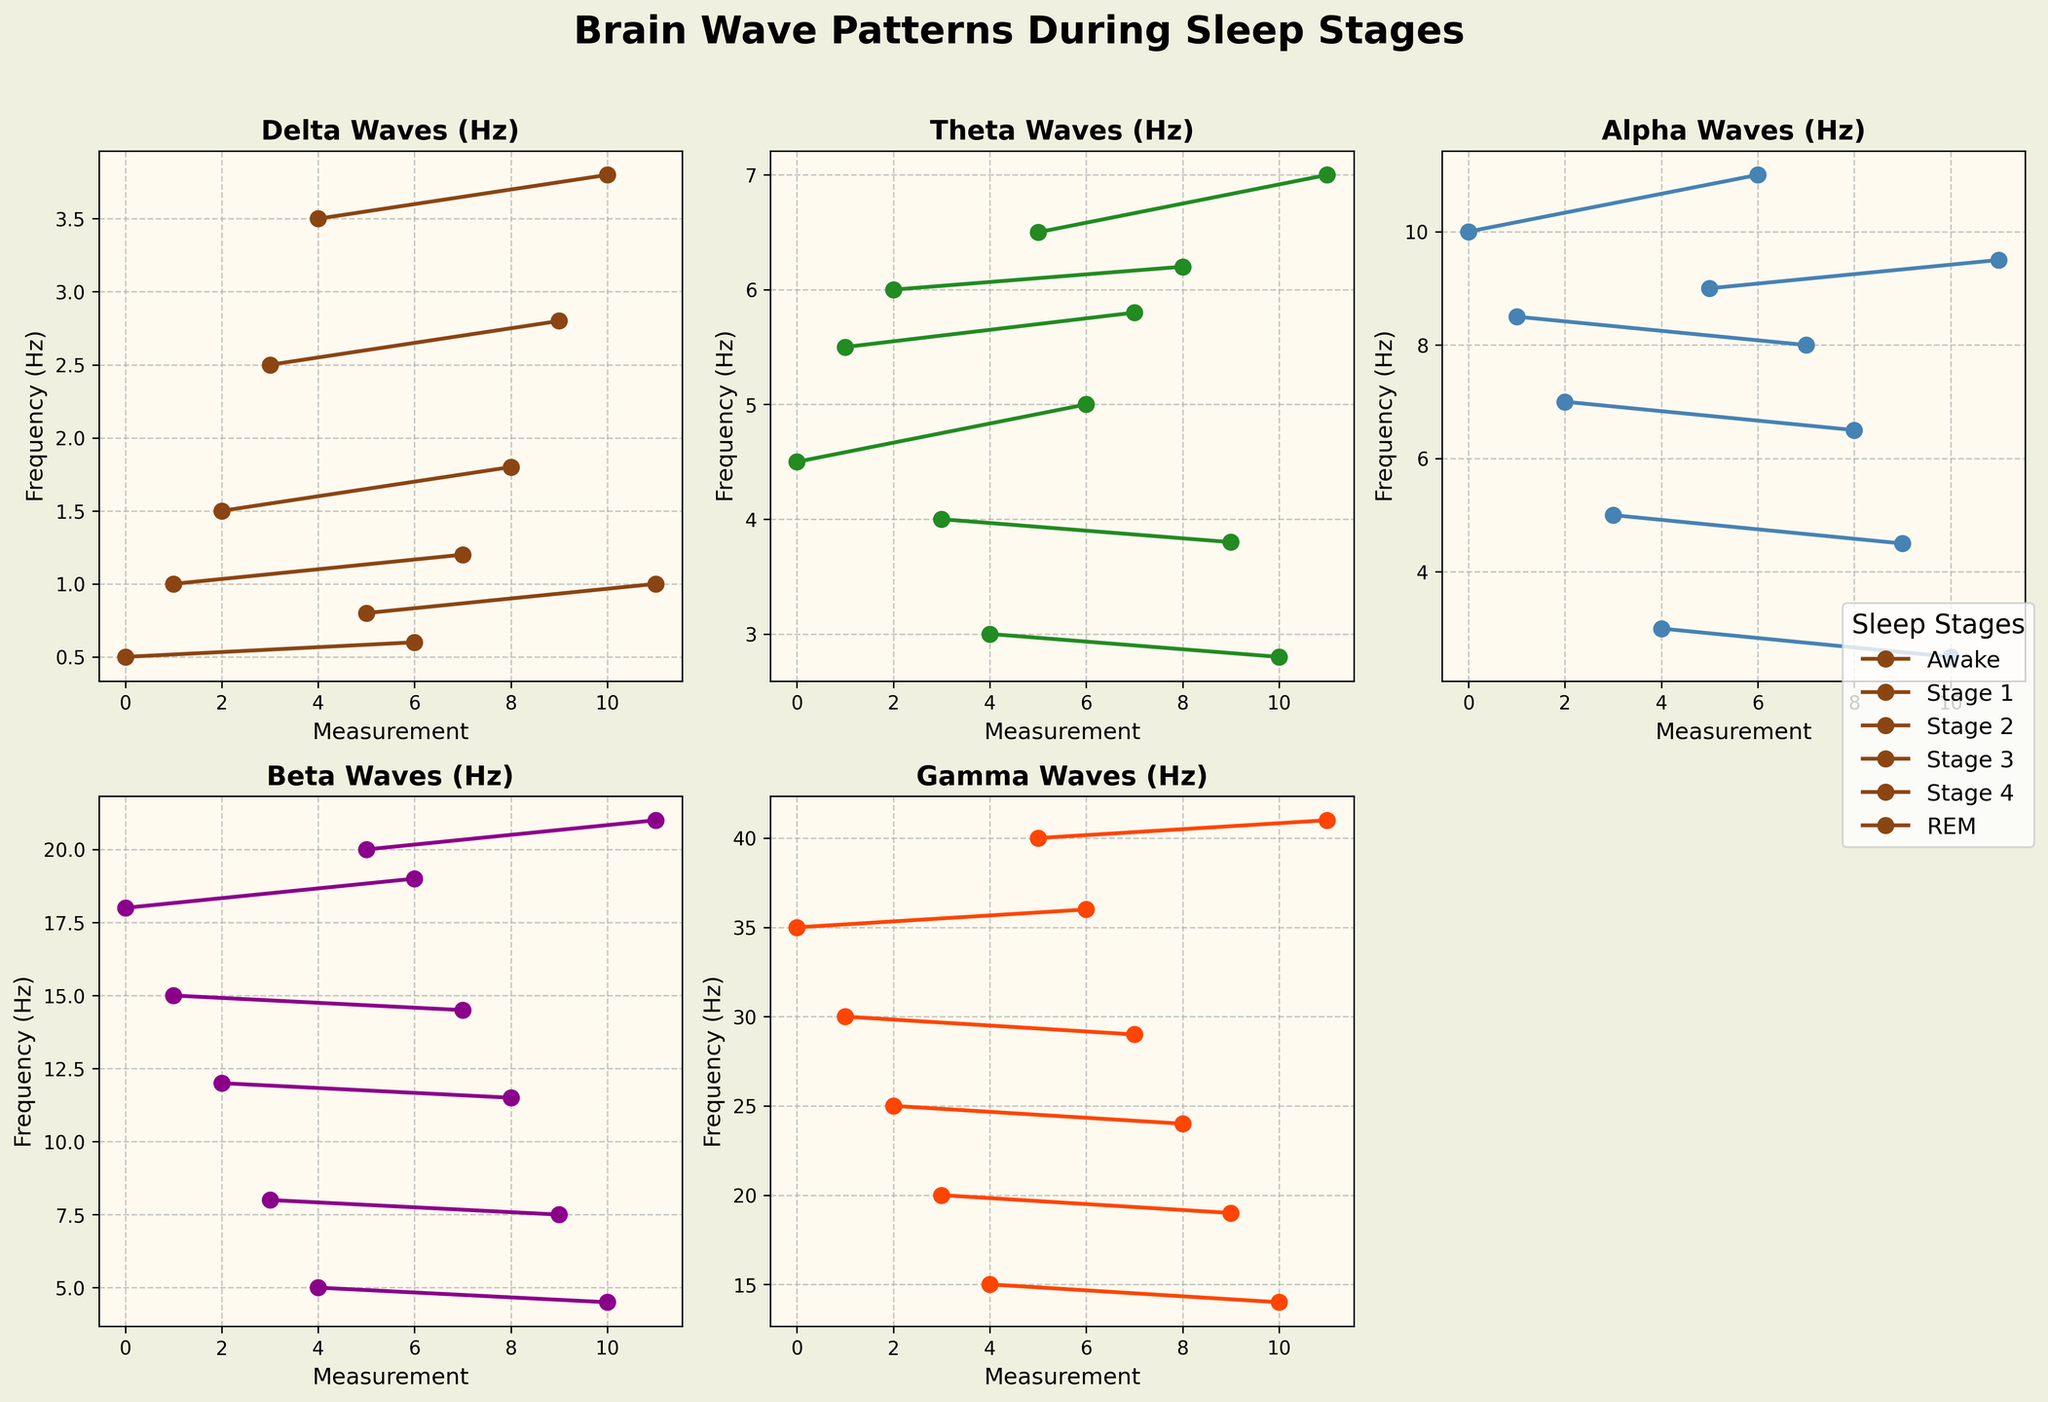What's the frequency range of Gamma Waves during REM sleep as compared to being Awake? The plot should show Gamma Waves in REM sleep and Awake stages. For REM sleep, Gamma Waves frequencies are likely represented by higher peaks, and for Awake stage, lower. If the plot shows 40 Hz for REM and 36 Hz for Awake, the difference is 4 Hz.
Answer: 40 Hz and 36 Hz Which sleep stage shows the highest frequency of Beta Waves? To find this, look at the Beta Waves plot and identify the highest overall peak among the different sleep stages. The REM stage generally shows the highest peaks in Beta Waves.
Answer: REM sleep What is the average Delta Waves frequency in Stage 4 sleep across both measurements? Look at the Delta Waves frequencies for Stage 4 sleep across both instances. If the values are 3.5 Hz and 3.8 Hz, then their average would be calculated as (3.5 + 3.8)/2 = 3.65 Hz.
Answer: 3.65 Hz How do Alpha Wave frequencies change from Stage 3 to Stage 4 sleep? Locate Alpha Wave plots for Stage 3 and Stage 4. Stage 3 typically shows higher frequencies, while Stage 4 has much lower ones. For instance, if Stage 3 frequencies are 5.0 Hz and 4.5 Hz, and Stage 4 shows 3.0 Hz and 2.5 Hz, the Alpha Waves decrease.
Answer: Decrease Which sleep stage has the lowest frequency of Theta Waves, and what is the frequency value? Search for the Theta Waves plot and find the lowest point among all sleep stages. If it's Stage 4 with frequencies around 3.0 Hz and 2.8 Hz, Stage 4 has the lowest values.
Answer: Stage 4, 2.8 Hz During which stage is there the least variation in Gamma Waves frequency? Examining the plot for Gamma Waves, we identify the stage with the smallest difference between its maximum and minimum values. If Stage 4 has consistent values close to 15 Hz and 14 Hz, it shows the least variation.
Answer: Stage 4 What is the difference in Beta Waves frequency between Awake and Stage 2? Refer to the plot of Beta Waves and observe the peaks for Awake and Stage 2. If Awake has values around 18.0 Hz and 19.0 Hz and Stage 2 has 12.0 Hz and 11.5 Hz, the difference is approximately 6.5 to 7 Hz.
Answer: 6.5-7 Hz How do Delta Waves frequencies typically transition from Awake to Stage 3? Review the Delta Waves plot transition from Awake to Stage 3. Delta Waves generally have lower frequencies in Awake and increase significantly by Stage 3. If Awake is around 0.5 Hz to 0.6 Hz and Stage 3 is 2.5 Hz to 2.8 Hz, there's an upward trend.
Answer: Increase What's the highest frequency recorded in Theta Waves, and in which stage does it occur? To answer this, look at the Theta Waves plot and identify the maximum peak. If REM sleep shows the highest peak, say, around 7.0 Hz, then REM sleep holds the highest frequency.
Answer: 7.0 Hz, REM sleep Which wave type shows the highest increase in frequency from Stage 1 to REM sleep? Compare the frequency increments in all wave plots from Stage 1 to REM. If we see Gamma Waves going from 30.0 Hz to 40.0 Hz, an increase of 10 Hz, Gamma Waves will have the highest increase compared to others.
Answer: Gamma Waves 